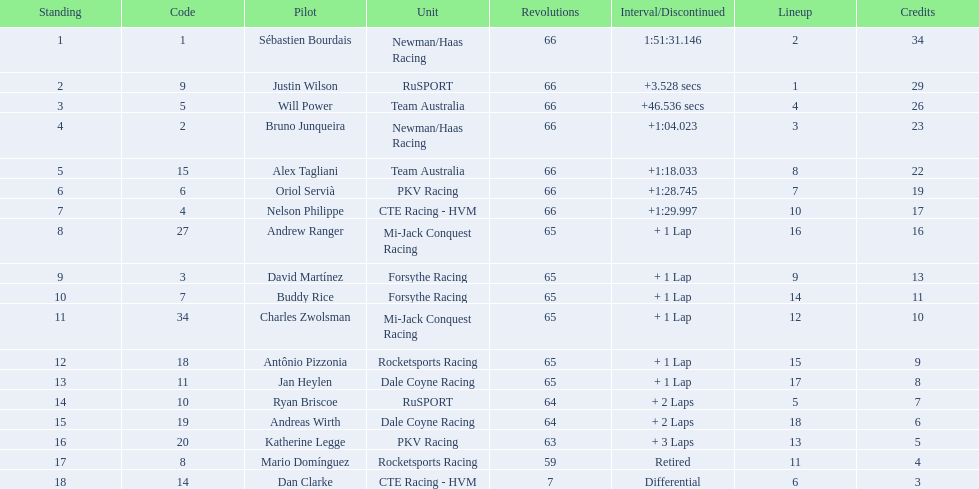What was the highest amount of points scored in the 2006 gran premio? 34. Who scored 34 points? Sébastien Bourdais. 